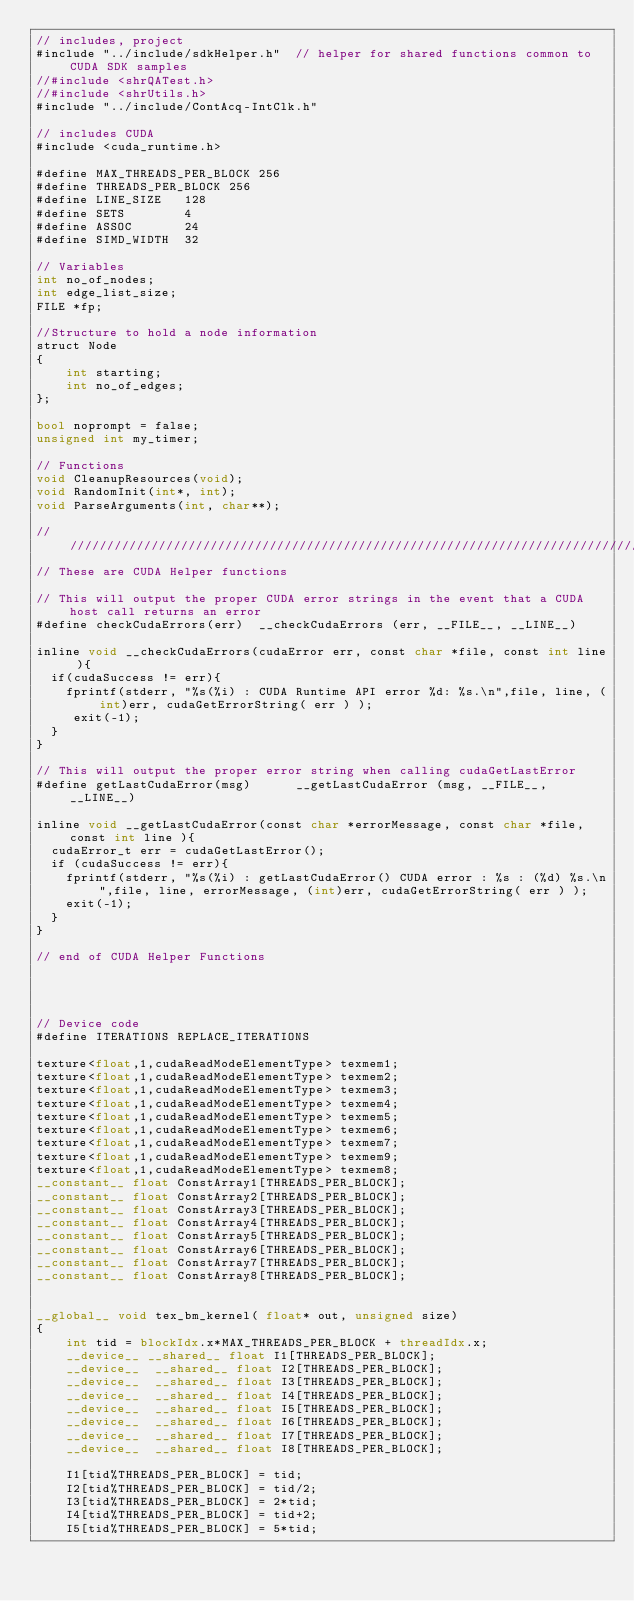<code> <loc_0><loc_0><loc_500><loc_500><_Cuda_>// includes, project
#include "../include/sdkHelper.h"  // helper for shared functions common to CUDA SDK samples
//#include <shrQATest.h>
//#include <shrUtils.h>
#include "../include/ContAcq-IntClk.h"

// includes CUDA
#include <cuda_runtime.h>

#define MAX_THREADS_PER_BLOCK 256
#define THREADS_PER_BLOCK 256
#define LINE_SIZE 	128
#define SETS		4
#define ASSOC		24
#define SIMD_WIDTH	32

// Variables
int no_of_nodes;
int edge_list_size;
FILE *fp;

//Structure to hold a node information
struct Node
{
	int starting;
	int no_of_edges;
};

bool noprompt = false;
unsigned int my_timer;

// Functions
void CleanupResources(void);
void RandomInit(int*, int);
void ParseArguments(int, char**);

////////////////////////////////////////////////////////////////////////////////
// These are CUDA Helper functions

// This will output the proper CUDA error strings in the event that a CUDA host call returns an error
#define checkCudaErrors(err)  __checkCudaErrors (err, __FILE__, __LINE__)

inline void __checkCudaErrors(cudaError err, const char *file, const int line ){
  if(cudaSuccess != err){
	fprintf(stderr, "%s(%i) : CUDA Runtime API error %d: %s.\n",file, line, (int)err, cudaGetErrorString( err ) );
	 exit(-1);
  }
}

// This will output the proper error string when calling cudaGetLastError
#define getLastCudaError(msg)      __getLastCudaError (msg, __FILE__, __LINE__)

inline void __getLastCudaError(const char *errorMessage, const char *file, const int line ){
  cudaError_t err = cudaGetLastError();
  if (cudaSuccess != err){
	fprintf(stderr, "%s(%i) : getLastCudaError() CUDA error : %s : (%d) %s.\n",file, line, errorMessage, (int)err, cudaGetErrorString( err ) );
	exit(-1);
  }
}

// end of CUDA Helper Functions




// Device code
#define ITERATIONS REPLACE_ITERATIONS

texture<float,1,cudaReadModeElementType> texmem1;
texture<float,1,cudaReadModeElementType> texmem2;
texture<float,1,cudaReadModeElementType> texmem3;
texture<float,1,cudaReadModeElementType> texmem4;
texture<float,1,cudaReadModeElementType> texmem5;
texture<float,1,cudaReadModeElementType> texmem6;
texture<float,1,cudaReadModeElementType> texmem7;
texture<float,1,cudaReadModeElementType> texmem9;
texture<float,1,cudaReadModeElementType> texmem8;
__constant__ float ConstArray1[THREADS_PER_BLOCK];
__constant__ float ConstArray2[THREADS_PER_BLOCK];
__constant__ float ConstArray3[THREADS_PER_BLOCK];
__constant__ float ConstArray4[THREADS_PER_BLOCK];
__constant__ float ConstArray5[THREADS_PER_BLOCK];
__constant__ float ConstArray6[THREADS_PER_BLOCK];
__constant__ float ConstArray7[THREADS_PER_BLOCK];
__constant__ float ConstArray8[THREADS_PER_BLOCK];


__global__ void tex_bm_kernel( float* out, unsigned size)
{
	int tid = blockIdx.x*MAX_THREADS_PER_BLOCK + threadIdx.x;
	__device__ __shared__ float I1[THREADS_PER_BLOCK];
    __device__  __shared__ float I2[THREADS_PER_BLOCK];
    __device__  __shared__ float I3[THREADS_PER_BLOCK];
    __device__  __shared__ float I4[THREADS_PER_BLOCK];
    __device__  __shared__ float I5[THREADS_PER_BLOCK];
    __device__  __shared__ float I6[THREADS_PER_BLOCK];
    __device__  __shared__ float I7[THREADS_PER_BLOCK];
    __device__  __shared__ float I8[THREADS_PER_BLOCK];

	I1[tid%THREADS_PER_BLOCK] = tid;
	I2[tid%THREADS_PER_BLOCK] = tid/2;
	I3[tid%THREADS_PER_BLOCK] = 2*tid;
	I4[tid%THREADS_PER_BLOCK] = tid+2;
	I5[tid%THREADS_PER_BLOCK] = 5*tid;</code> 